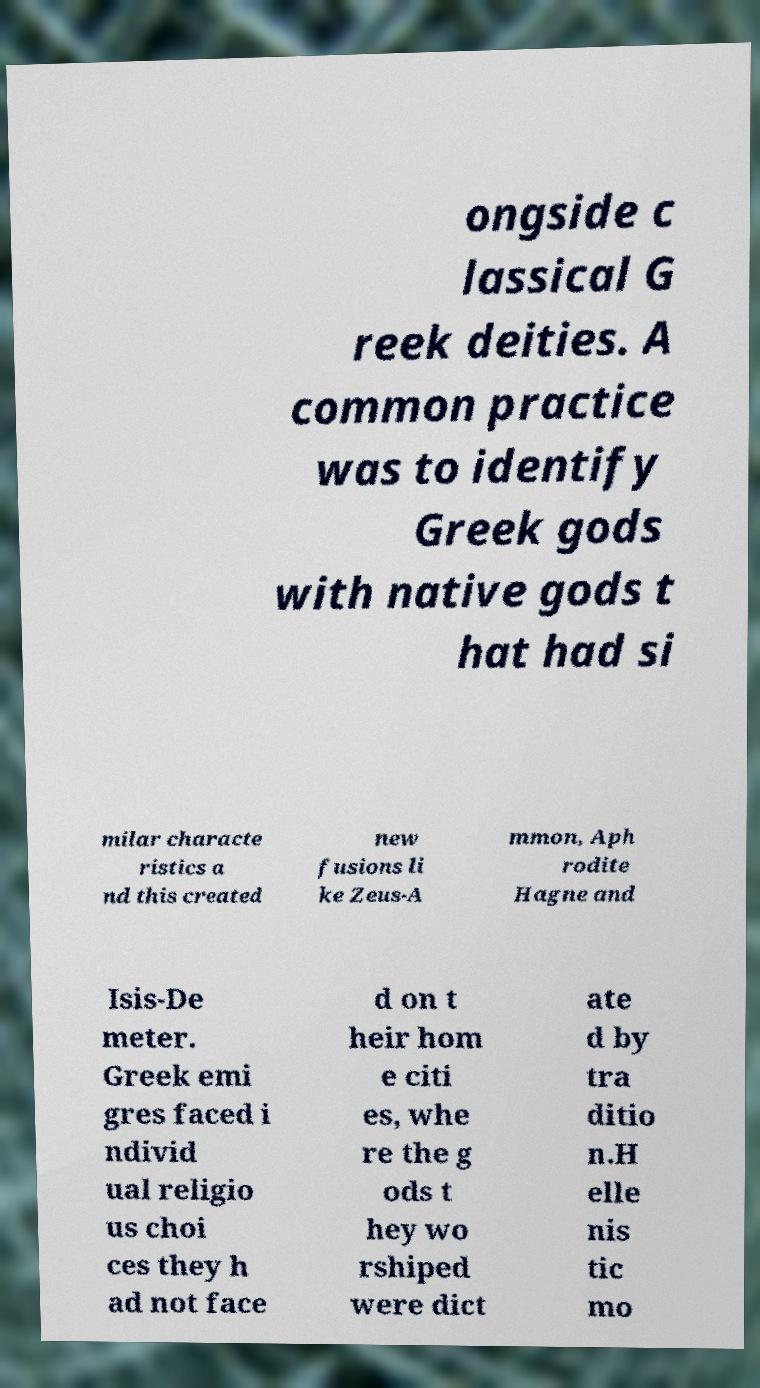Can you read and provide the text displayed in the image?This photo seems to have some interesting text. Can you extract and type it out for me? ongside c lassical G reek deities. A common practice was to identify Greek gods with native gods t hat had si milar characte ristics a nd this created new fusions li ke Zeus-A mmon, Aph rodite Hagne and Isis-De meter. Greek emi gres faced i ndivid ual religio us choi ces they h ad not face d on t heir hom e citi es, whe re the g ods t hey wo rshiped were dict ate d by tra ditio n.H elle nis tic mo 